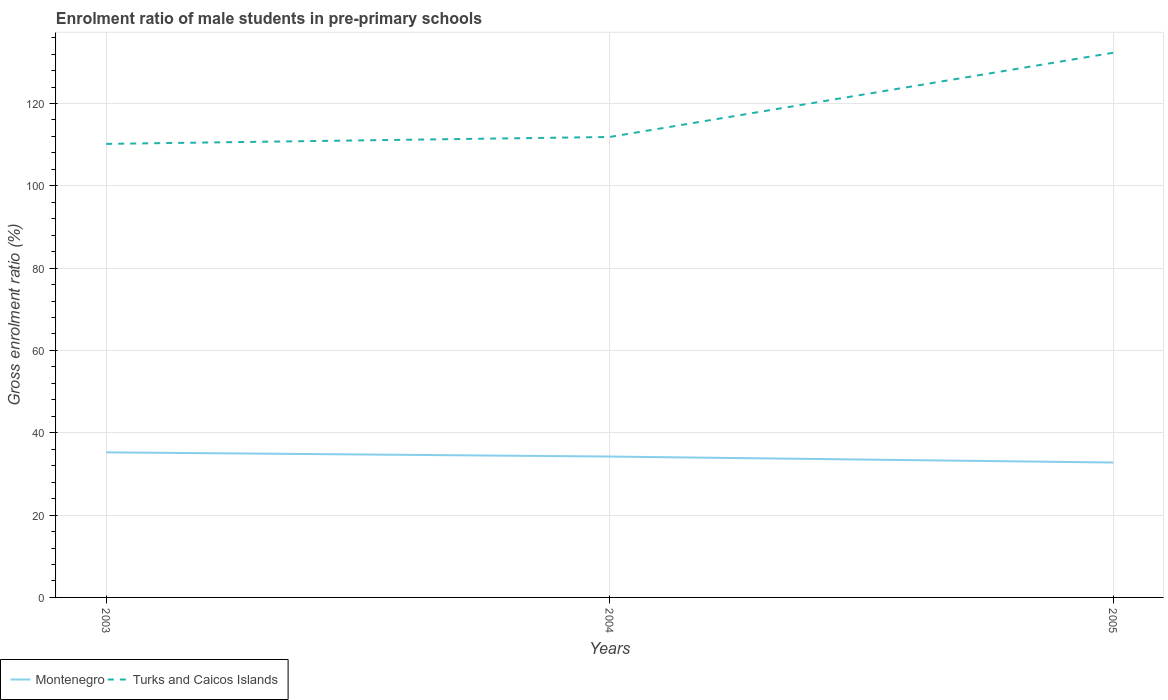Is the number of lines equal to the number of legend labels?
Make the answer very short. Yes. Across all years, what is the maximum enrolment ratio of male students in pre-primary schools in Montenegro?
Offer a very short reply. 32.78. What is the total enrolment ratio of male students in pre-primary schools in Turks and Caicos Islands in the graph?
Keep it short and to the point. -1.68. What is the difference between the highest and the second highest enrolment ratio of male students in pre-primary schools in Turks and Caicos Islands?
Your response must be concise. 22.14. What is the difference between the highest and the lowest enrolment ratio of male students in pre-primary schools in Montenegro?
Make the answer very short. 2. What is the difference between two consecutive major ticks on the Y-axis?
Keep it short and to the point. 20. Does the graph contain any zero values?
Ensure brevity in your answer.  No. Does the graph contain grids?
Ensure brevity in your answer.  Yes. How many legend labels are there?
Make the answer very short. 2. What is the title of the graph?
Give a very brief answer. Enrolment ratio of male students in pre-primary schools. Does "Brunei Darussalam" appear as one of the legend labels in the graph?
Your answer should be compact. No. What is the label or title of the X-axis?
Ensure brevity in your answer.  Years. What is the Gross enrolment ratio (%) of Montenegro in 2003?
Provide a succinct answer. 35.25. What is the Gross enrolment ratio (%) in Turks and Caicos Islands in 2003?
Ensure brevity in your answer.  110.19. What is the Gross enrolment ratio (%) in Montenegro in 2004?
Your response must be concise. 34.23. What is the Gross enrolment ratio (%) of Turks and Caicos Islands in 2004?
Ensure brevity in your answer.  111.87. What is the Gross enrolment ratio (%) of Montenegro in 2005?
Your answer should be very brief. 32.78. What is the Gross enrolment ratio (%) of Turks and Caicos Islands in 2005?
Your response must be concise. 132.33. Across all years, what is the maximum Gross enrolment ratio (%) in Montenegro?
Your answer should be compact. 35.25. Across all years, what is the maximum Gross enrolment ratio (%) of Turks and Caicos Islands?
Your response must be concise. 132.33. Across all years, what is the minimum Gross enrolment ratio (%) of Montenegro?
Keep it short and to the point. 32.78. Across all years, what is the minimum Gross enrolment ratio (%) of Turks and Caicos Islands?
Make the answer very short. 110.19. What is the total Gross enrolment ratio (%) of Montenegro in the graph?
Your answer should be very brief. 102.25. What is the total Gross enrolment ratio (%) in Turks and Caicos Islands in the graph?
Provide a succinct answer. 354.39. What is the difference between the Gross enrolment ratio (%) of Montenegro in 2003 and that in 2004?
Your answer should be very brief. 1.02. What is the difference between the Gross enrolment ratio (%) of Turks and Caicos Islands in 2003 and that in 2004?
Ensure brevity in your answer.  -1.68. What is the difference between the Gross enrolment ratio (%) of Montenegro in 2003 and that in 2005?
Provide a succinct answer. 2.47. What is the difference between the Gross enrolment ratio (%) of Turks and Caicos Islands in 2003 and that in 2005?
Your answer should be very brief. -22.14. What is the difference between the Gross enrolment ratio (%) of Montenegro in 2004 and that in 2005?
Keep it short and to the point. 1.45. What is the difference between the Gross enrolment ratio (%) in Turks and Caicos Islands in 2004 and that in 2005?
Give a very brief answer. -20.46. What is the difference between the Gross enrolment ratio (%) in Montenegro in 2003 and the Gross enrolment ratio (%) in Turks and Caicos Islands in 2004?
Your response must be concise. -76.62. What is the difference between the Gross enrolment ratio (%) in Montenegro in 2003 and the Gross enrolment ratio (%) in Turks and Caicos Islands in 2005?
Offer a terse response. -97.08. What is the difference between the Gross enrolment ratio (%) of Montenegro in 2004 and the Gross enrolment ratio (%) of Turks and Caicos Islands in 2005?
Offer a very short reply. -98.1. What is the average Gross enrolment ratio (%) in Montenegro per year?
Your answer should be compact. 34.08. What is the average Gross enrolment ratio (%) in Turks and Caicos Islands per year?
Offer a very short reply. 118.13. In the year 2003, what is the difference between the Gross enrolment ratio (%) of Montenegro and Gross enrolment ratio (%) of Turks and Caicos Islands?
Ensure brevity in your answer.  -74.94. In the year 2004, what is the difference between the Gross enrolment ratio (%) in Montenegro and Gross enrolment ratio (%) in Turks and Caicos Islands?
Provide a succinct answer. -77.64. In the year 2005, what is the difference between the Gross enrolment ratio (%) in Montenegro and Gross enrolment ratio (%) in Turks and Caicos Islands?
Provide a short and direct response. -99.56. What is the ratio of the Gross enrolment ratio (%) in Montenegro in 2003 to that in 2004?
Your response must be concise. 1.03. What is the ratio of the Gross enrolment ratio (%) of Turks and Caicos Islands in 2003 to that in 2004?
Keep it short and to the point. 0.98. What is the ratio of the Gross enrolment ratio (%) of Montenegro in 2003 to that in 2005?
Your answer should be very brief. 1.08. What is the ratio of the Gross enrolment ratio (%) in Turks and Caicos Islands in 2003 to that in 2005?
Your answer should be compact. 0.83. What is the ratio of the Gross enrolment ratio (%) of Montenegro in 2004 to that in 2005?
Give a very brief answer. 1.04. What is the ratio of the Gross enrolment ratio (%) of Turks and Caicos Islands in 2004 to that in 2005?
Your answer should be compact. 0.85. What is the difference between the highest and the second highest Gross enrolment ratio (%) of Montenegro?
Make the answer very short. 1.02. What is the difference between the highest and the second highest Gross enrolment ratio (%) of Turks and Caicos Islands?
Your answer should be very brief. 20.46. What is the difference between the highest and the lowest Gross enrolment ratio (%) of Montenegro?
Offer a terse response. 2.47. What is the difference between the highest and the lowest Gross enrolment ratio (%) of Turks and Caicos Islands?
Your response must be concise. 22.14. 